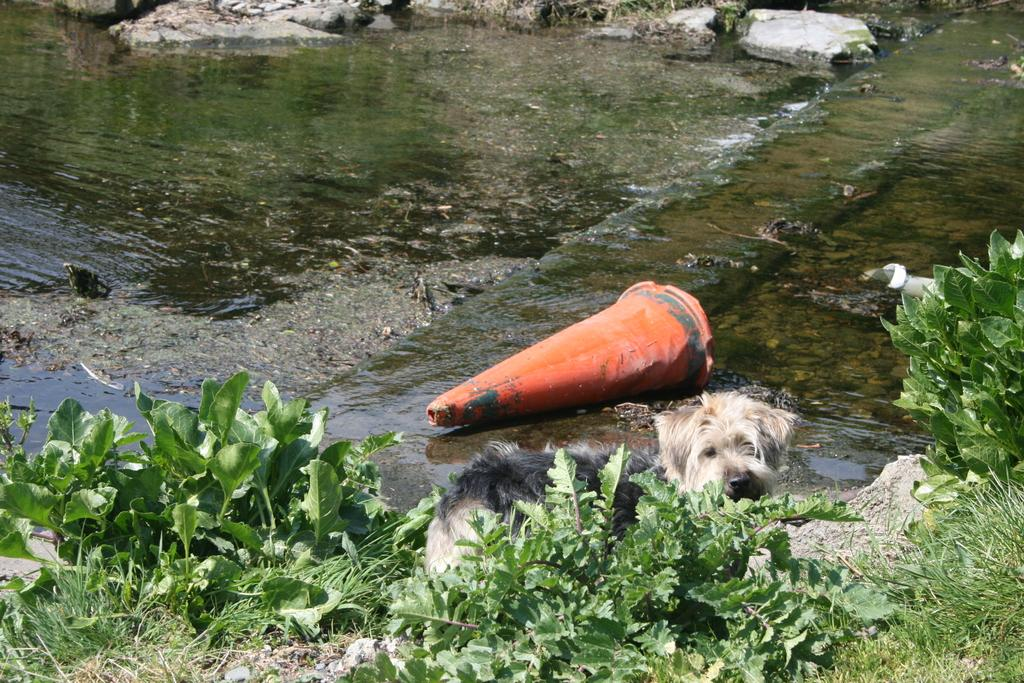What type of animal can be seen in the image? There is a dog in the image. Where is the dog located in relation to the plant? The dog is behind a plant in the image. What is the object in the image? The facts do not specify the object, so we cannot answer this question definitively. What type of natural elements are visible in the image? Rocks, plants, grass, and water are visible in the image. What type of coat is the dog wearing in the image? The facts do not mention a coat, and there is no indication that the dog is wearing one in the image. How does the loaf of bread fit into the image? There is no loaf of bread present in the image. 